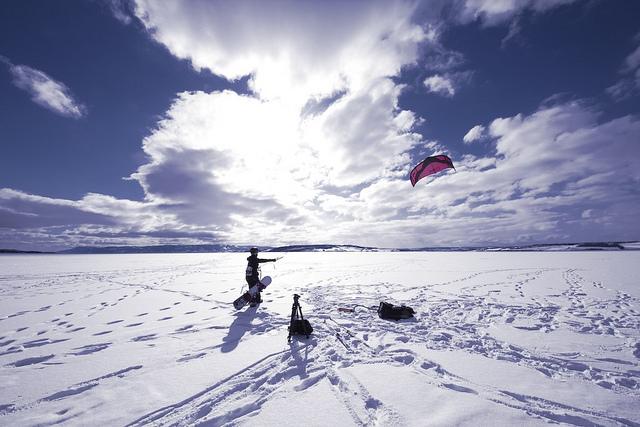Where is the sun located in this picture?
Short answer required. Behind clouds. What is this man doing?
Write a very short answer. Flying kite. Is this a ocean?
Short answer required. No. What has caused the lines crossing the snow?
Keep it brief. People. Could this sail to the snowboarder?
Give a very brief answer. Yes. 